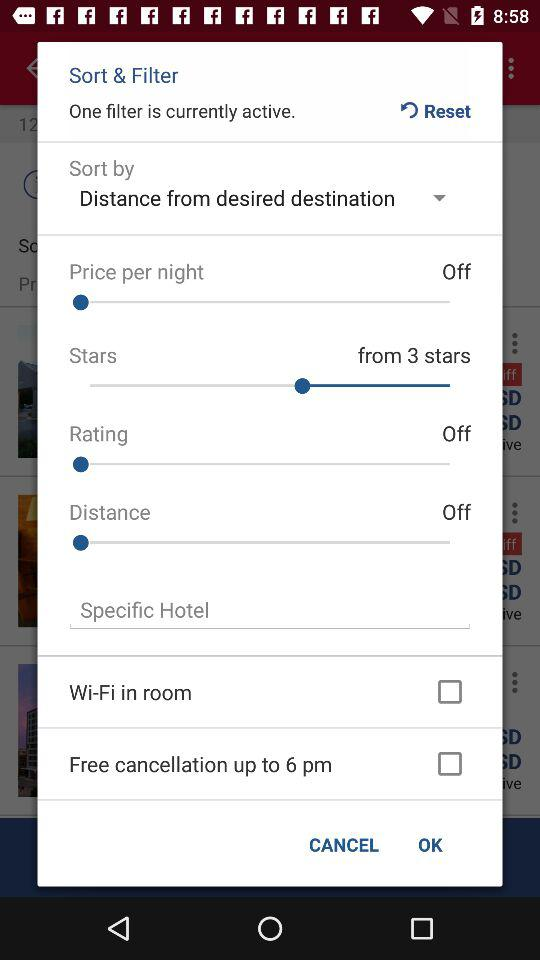How many filters are currently active? The number of currently active filters is one. 